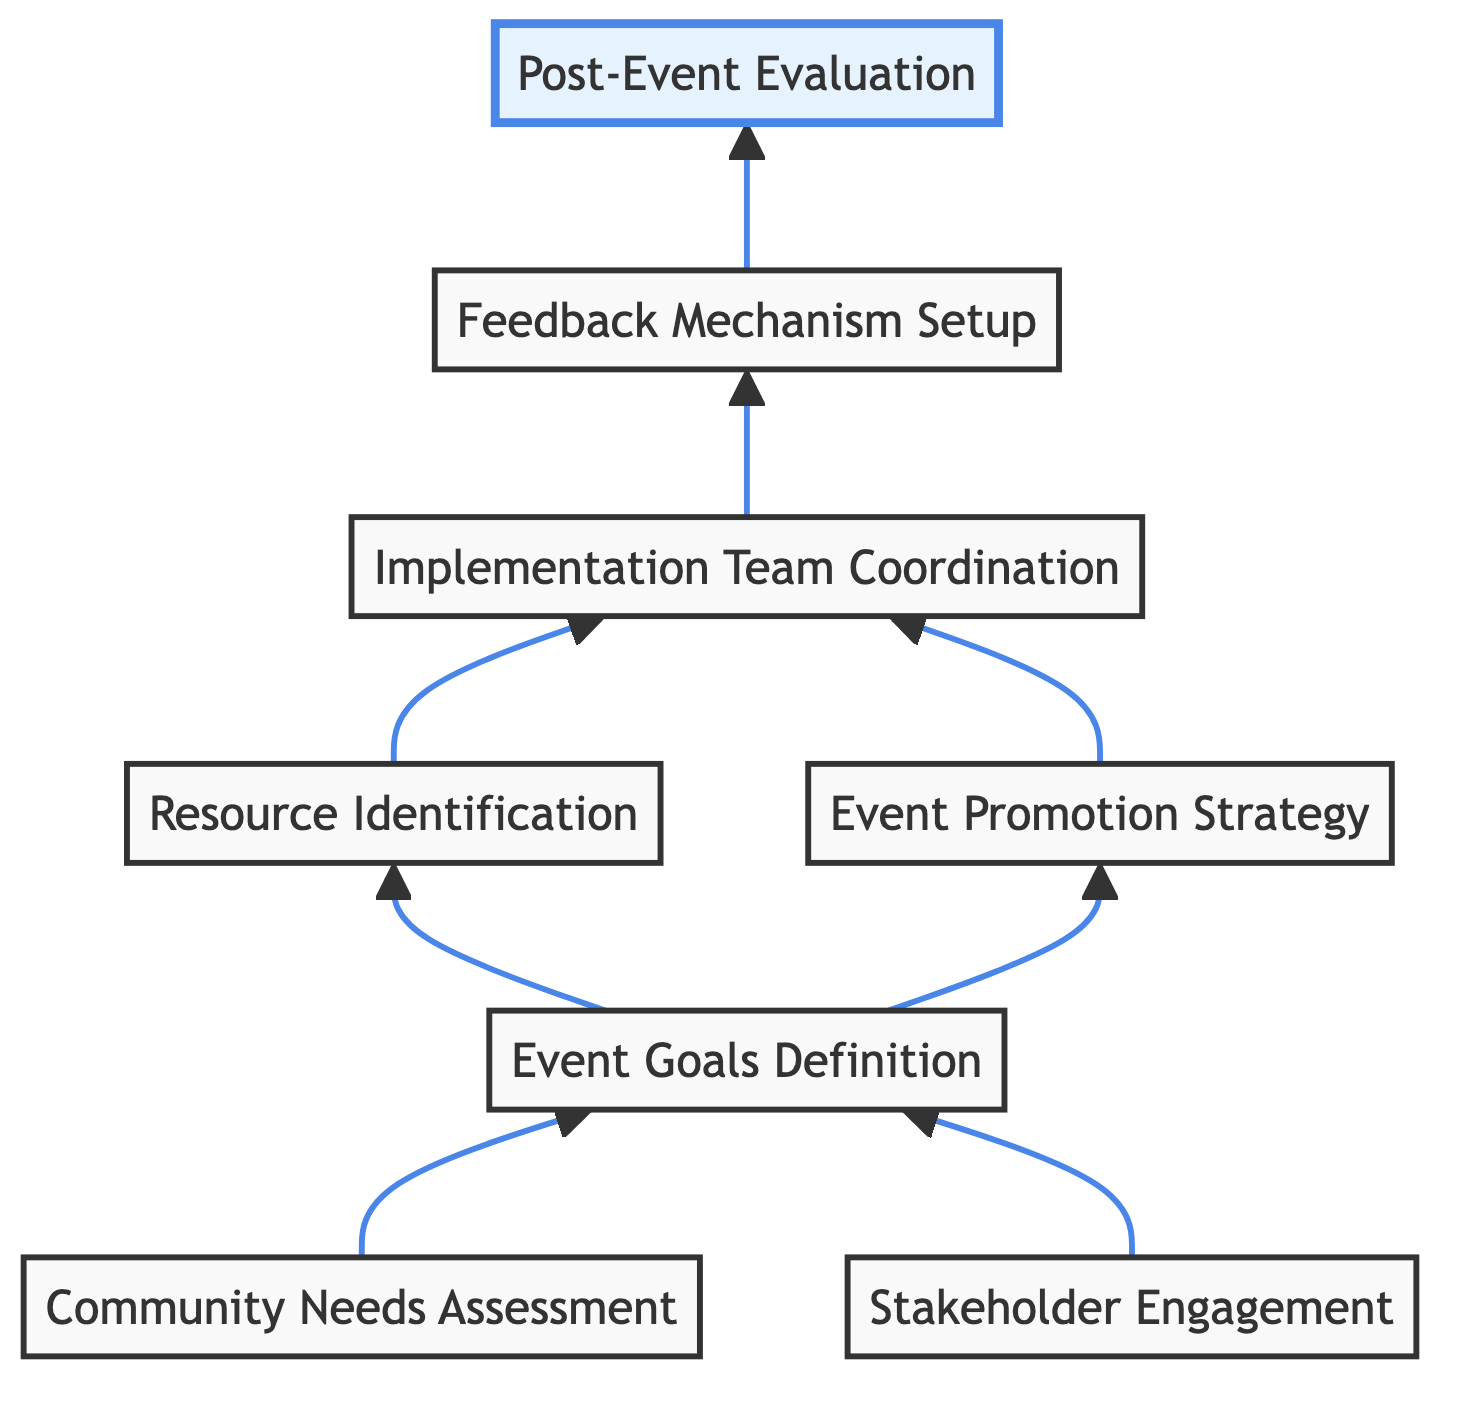What is the first step in the process? The diagram depicts a flow starting from the "Community Needs Assessment" node, which is the first action to undertake in the planning process.
Answer: Community Needs Assessment How many nodes are there in the diagram? The diagram features eight distinct nodes that represent different steps in the community outreach event planning process.
Answer: 8 What follows the "Stakeholder Engagement"? "Event Goals Definition" is the subsequent node that follows "Stakeholder Engagement," indicating that gathering stakeholder input leads to defining the objectives for the event.
Answer: Event Goals Definition Which nodes lead to the "Implementation Team Coordination"? Both "Resource Identification" and "Event Promotion Strategy" nodes direct to "Implementation Team Coordination," meaning resources and promotions are crucial for team coordination.
Answer: Resource Identification, Event Promotion Strategy What is the last step in the diagram? The final step indicated in the flowchart is "Post-Event Evaluation," which comes after collecting feedback from the participants.
Answer: Post-Event Evaluation What do the arrows between nodes represent? The arrows illustrate the flow of the process, showing the order of steps and how each action leads to the next within the outreach event planning.
Answer: Flow of process Which node summarizes the entire planning process? The "Post-Event Evaluation" node serves as a summary of the entire planning process since it assesses the impact and insights gathered from the event.
Answer: Post-Event Evaluation Which steps are directly linked to "Event Goals Definition"? Both "Community Needs Assessment" and "Stakeholder Engagement" are directly linked to "Event Goals Definition," as they both inform the objectives for the event.
Answer: Community Needs Assessment, Stakeholder Engagement 